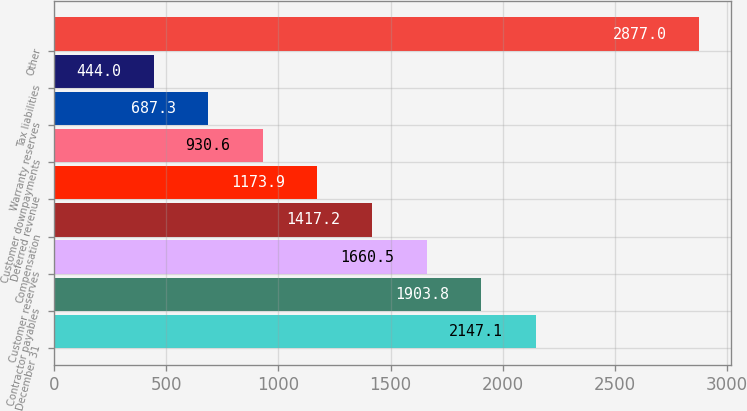Convert chart. <chart><loc_0><loc_0><loc_500><loc_500><bar_chart><fcel>December 31<fcel>Contractor payables<fcel>Customer reserves<fcel>Compensation<fcel>Deferred revenue<fcel>Customer downpayments<fcel>Warranty reserves<fcel>Tax liabilities<fcel>Other<nl><fcel>2147.1<fcel>1903.8<fcel>1660.5<fcel>1417.2<fcel>1173.9<fcel>930.6<fcel>687.3<fcel>444<fcel>2877<nl></chart> 